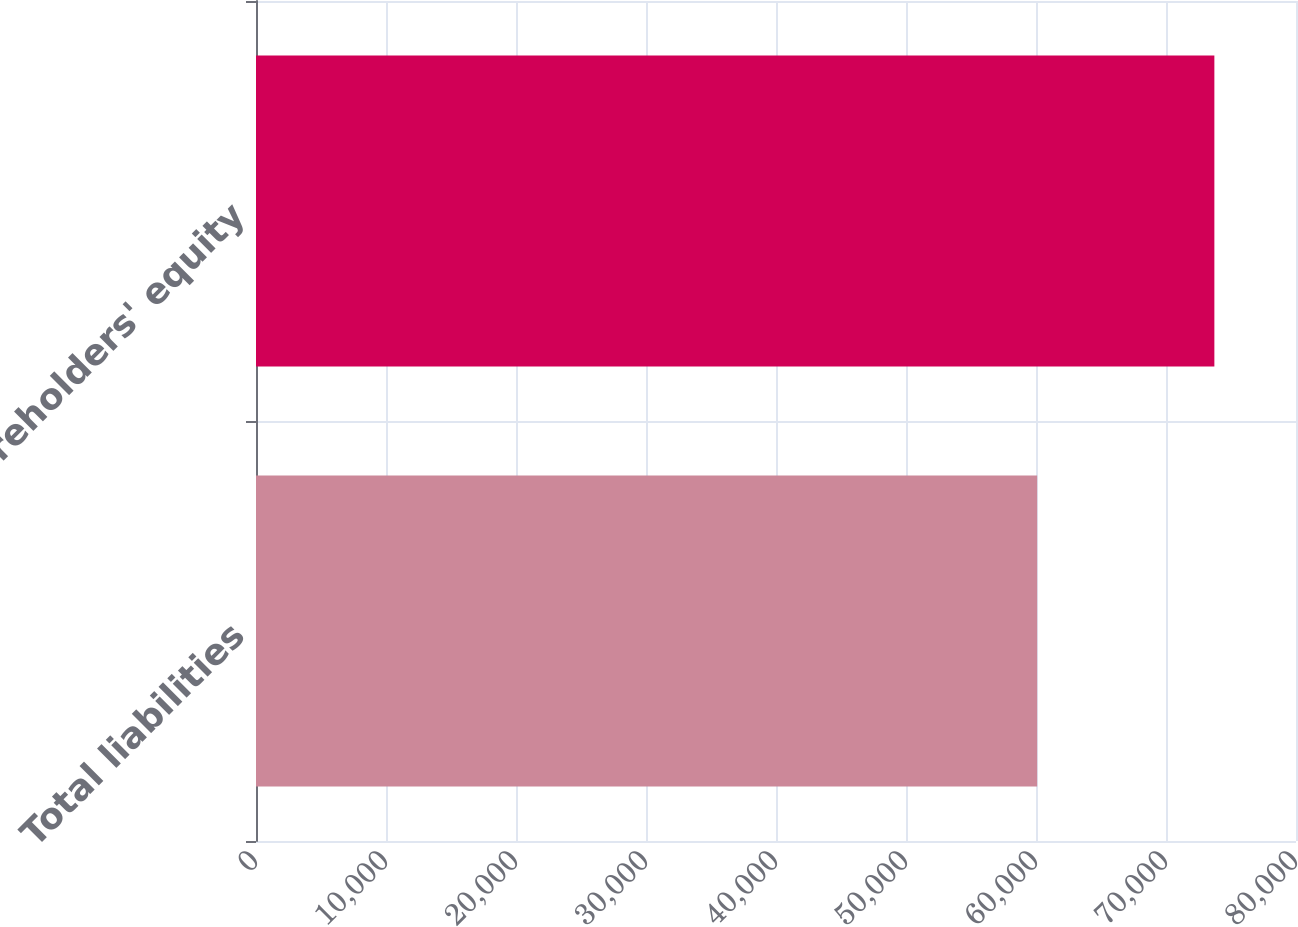Convert chart. <chart><loc_0><loc_0><loc_500><loc_500><bar_chart><fcel>Total liabilities<fcel>shareholders' equity<nl><fcel>60088.4<fcel>73720.3<nl></chart> 